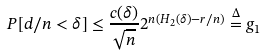Convert formula to latex. <formula><loc_0><loc_0><loc_500><loc_500>P [ d / n < \delta ] \leq \frac { c ( \delta ) } { \sqrt { n } } 2 ^ { n ( H _ { 2 } ( \delta ) - r / n ) } \stackrel { \Delta } { = } g _ { 1 }</formula> 